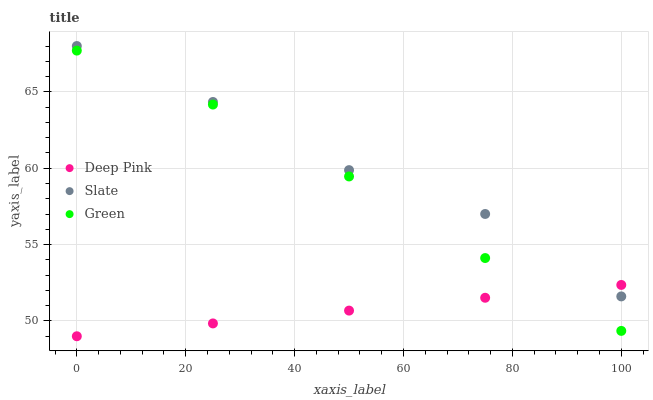Does Deep Pink have the minimum area under the curve?
Answer yes or no. Yes. Does Slate have the maximum area under the curve?
Answer yes or no. Yes. Does Green have the minimum area under the curve?
Answer yes or no. No. Does Green have the maximum area under the curve?
Answer yes or no. No. Is Deep Pink the smoothest?
Answer yes or no. Yes. Is Slate the roughest?
Answer yes or no. Yes. Is Green the smoothest?
Answer yes or no. No. Is Green the roughest?
Answer yes or no. No. Does Deep Pink have the lowest value?
Answer yes or no. Yes. Does Green have the lowest value?
Answer yes or no. No. Does Slate have the highest value?
Answer yes or no. Yes. Does Green have the highest value?
Answer yes or no. No. Is Green less than Slate?
Answer yes or no. Yes. Is Slate greater than Green?
Answer yes or no. Yes. Does Deep Pink intersect Slate?
Answer yes or no. Yes. Is Deep Pink less than Slate?
Answer yes or no. No. Is Deep Pink greater than Slate?
Answer yes or no. No. Does Green intersect Slate?
Answer yes or no. No. 